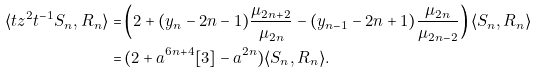Convert formula to latex. <formula><loc_0><loc_0><loc_500><loc_500>\langle t z ^ { 2 } t ^ { - 1 } S _ { n } , R _ { n } \rangle = & \left ( 2 + ( y _ { n } - 2 n - 1 ) \frac { \mu _ { 2 n + 2 } } { \mu _ { 2 n } } - ( y _ { n - 1 } - 2 n + 1 ) \frac { \mu _ { 2 n } } { \mu _ { 2 n - 2 } } \right ) \langle S _ { n } , R _ { n } \rangle \\ = & \, ( 2 + a ^ { 6 n + 4 } [ 3 ] - a ^ { 2 n } ) \langle S _ { n } , R _ { n } \rangle .</formula> 